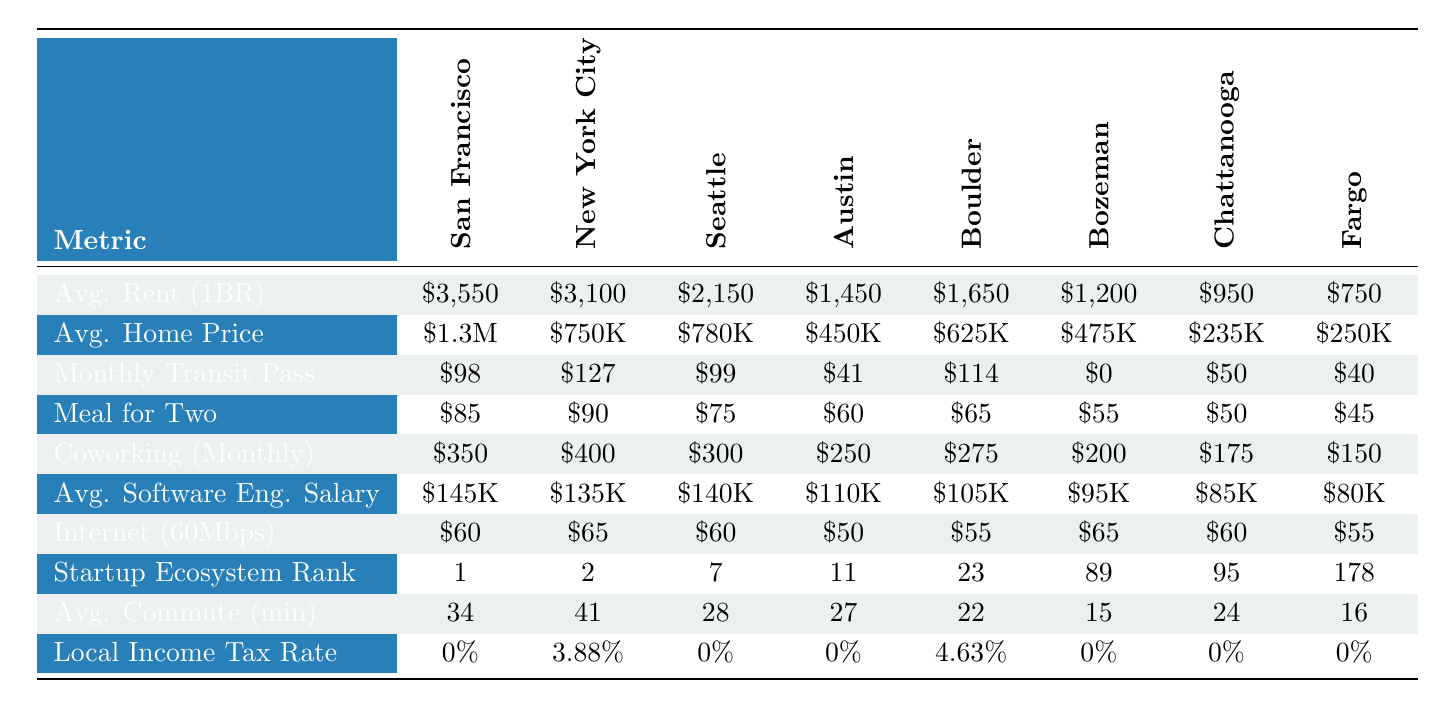What is the average rent for a 1-bedroom apartment in San Francisco? The table provides the average rent for a 1-bedroom apartment in San Francisco as $3,550.
Answer: $3,550 Which city has the highest average home price? By comparing the values in the "Average Home Price" row, San Francisco has the highest average home price at $1.3 million.
Answer: San Francisco What is the average salary of a software engineer in Austin? According to the table, the average salary of a software engineer in Austin is $110,000.
Answer: $110,000 How much does a monthly public transport pass cost in New York City? The table lists the cost of a monthly public transport pass in New York City as $127.
Answer: $127 Which city has the lowest average rent? By reviewing the rent figures, Fargo has the lowest average rent for a 1-bedroom apartment at $750.
Answer: Fargo What is the average commute time in Bozeman? The table indicates that the average commute time in Bozeman is 15 minutes.
Answer: 15 minutes What is the difference in average home prices between New York City and Chattanooga? The average home price in New York City is $750,000 and in Chattanooga it is $235,000. The difference is $750,000 - $235,000 = $515,000.
Answer: $515,000 Is there a local income tax rate in Seattle? The table shows that the local income tax rate in Seattle is 0%, indicating there is no local income tax.
Answer: No Which city has both a higher average software engineer salary and a higher startup ecosystem ranking compared to Austin? Comparing both metrics, San Francisco has an average salary of $145,000 and a startup ecosystem ranking of 1, which is higher than Austin's $110,000 and 11 ranking respectively.
Answer: San Francisco If you average the monthly costs for coworking spaces in Boulder and Chattanooga, what is the result? The monthly costs are $275 for Boulder and $175 for Chattanooga. The average is ($275 + $175) / 2 = $225.
Answer: $225 How many cities have a local income tax rate higher than 0%? Looking at the table, only New York City and Boulder have a local income tax rate greater than 0%, making it a total of 2 cities.
Answer: 2 cities What is the average internet cost across all locations in this table? To find the average: (60 + 65 + 60 + 50 + 55 + 65 + 60 + 55) / 8 = $57.5, so the average internet cost is $57.5.
Answer: $57.5 Which tech hub has the lowest average meal cost for two at a mid-range restaurant? The table indicates that Fargo has the lowest average meal cost for two at a mid-range restaurant, costing $45.
Answer: Fargo Is Austin more affordable than Bozeman when considering the average rent and average home prices? Austin averages $1,450 for rent and $450,000 for home prices compared to Bozeman’s $1,200 rent and $475,000 home price, so Austin is more expensive in terms of rent but less expensive for home prices, requiring further analysis to conclude affordability.
Answer: Mixed results; specific context required 